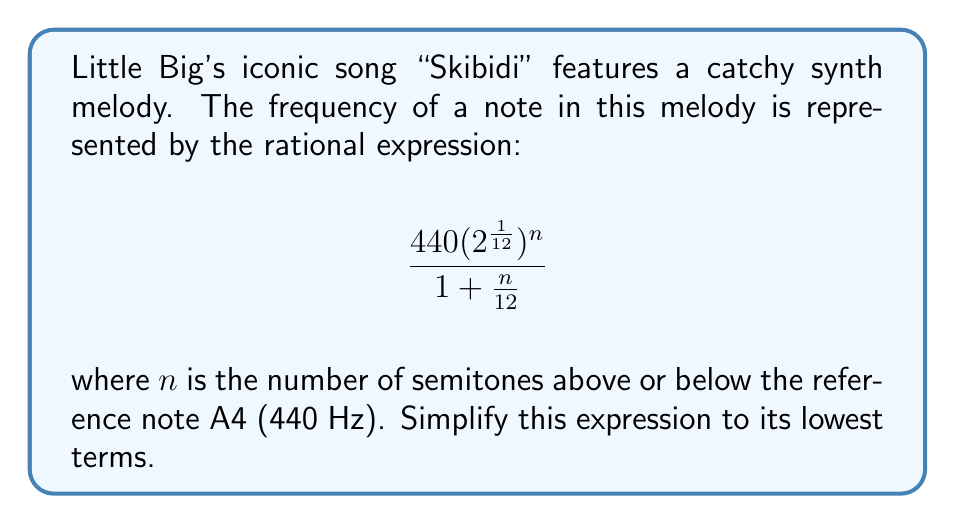Could you help me with this problem? Let's simplify this rational expression step-by-step:

1) First, let's focus on the numerator:
   $440(2^{\frac{1}{12}})^n$ can be rewritten as $440 \cdot 2^{\frac{n}{12}}$

2) Now, our expression looks like this:
   $$\frac{440 \cdot 2^{\frac{n}{12}}}{1 + \frac{n}{12}}$$

3) To simplify further, we need to find a common denominator in the fraction. The denominator already has 12, so let's multiply the numerator and denominator by 12:

   $$\frac{440 \cdot 2^{\frac{n}{12}} \cdot 12}{(1 + \frac{n}{12}) \cdot 12}$$

4) Simplify:
   $$\frac{5280 \cdot 2^{\frac{n}{12}}}{12 + n}$$

5) This is now in its simplest form. We can't factor out any common terms from the numerator and denominator.
Answer: $$\frac{5280 \cdot 2^{\frac{n}{12}}}{12 + n}$$ 